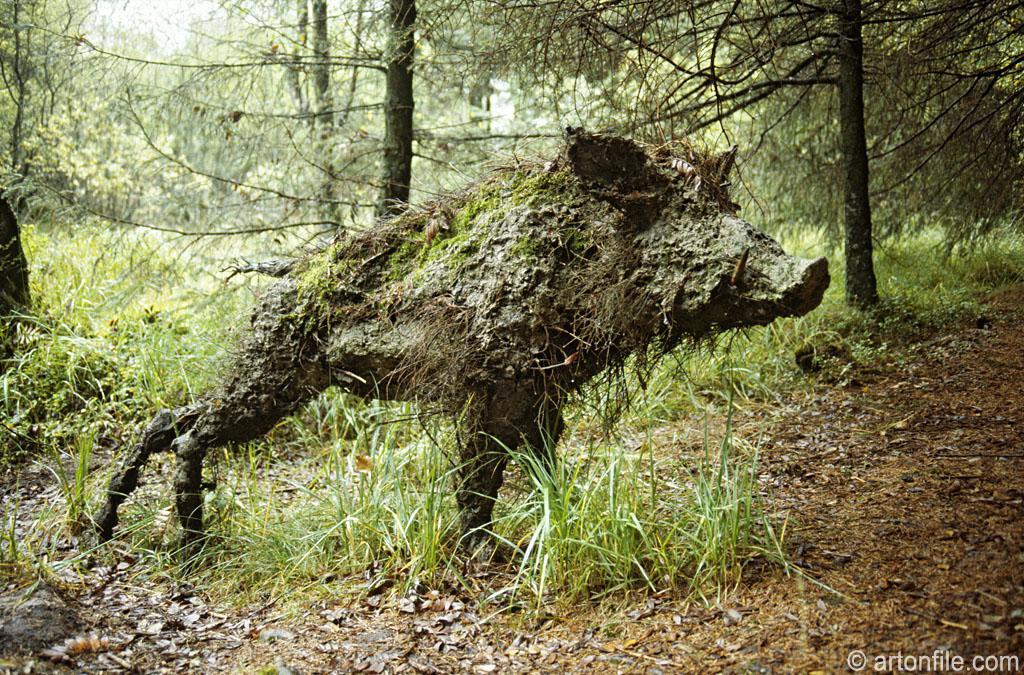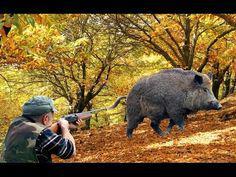The first image is the image on the left, the second image is the image on the right. Evaluate the accuracy of this statement regarding the images: "A pig is on its side.". Is it true? Answer yes or no. No. The first image is the image on the left, the second image is the image on the right. Considering the images on both sides, is "There is at least one person in one of the photos." valid? Answer yes or no. Yes. 